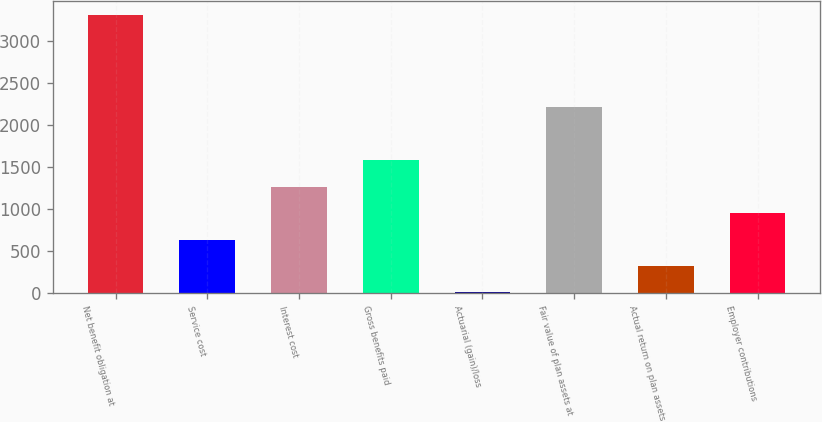Convert chart to OTSL. <chart><loc_0><loc_0><loc_500><loc_500><bar_chart><fcel>Net benefit obligation at<fcel>Service cost<fcel>Interest cost<fcel>Gross benefits paid<fcel>Actuarial (gain)/loss<fcel>Fair value of plan assets at<fcel>Actual return on plan assets<fcel>Employer contributions<nl><fcel>3306.5<fcel>637<fcel>1266<fcel>1580.5<fcel>8<fcel>2209.5<fcel>322.5<fcel>951.5<nl></chart> 